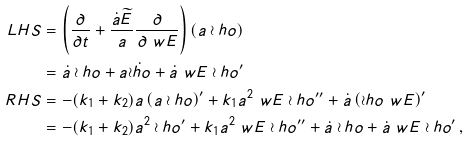<formula> <loc_0><loc_0><loc_500><loc_500>L H S & = \left ( \frac { \partial } { \partial t } + \frac { \dot { a } \widetilde { E } } { a } \frac { \partial } { \partial \ w E } \right ) \left ( a \wr h o \right ) \\ & = \dot { a } \wr h o + a \dot { \wr h o } + \dot { a } \ w E \wr h o ^ { \prime } \\ R H S & = - ( k _ { 1 } + k _ { 2 } ) a \left ( a \wr h o \right ) ^ { \prime } + k _ { 1 } a ^ { 2 } \ w E \wr h o ^ { \prime \prime } + \dot { a } \left ( \wr h o \ w E \right ) ^ { \prime } \\ & = - ( k _ { 1 } + k _ { 2 } ) a ^ { 2 } \wr h o ^ { \prime } + k _ { 1 } a ^ { 2 } \ w E \wr h o ^ { \prime \prime } + \dot { a } \wr h o + \dot { a } \ w E \wr h o ^ { \prime } \, ,</formula> 